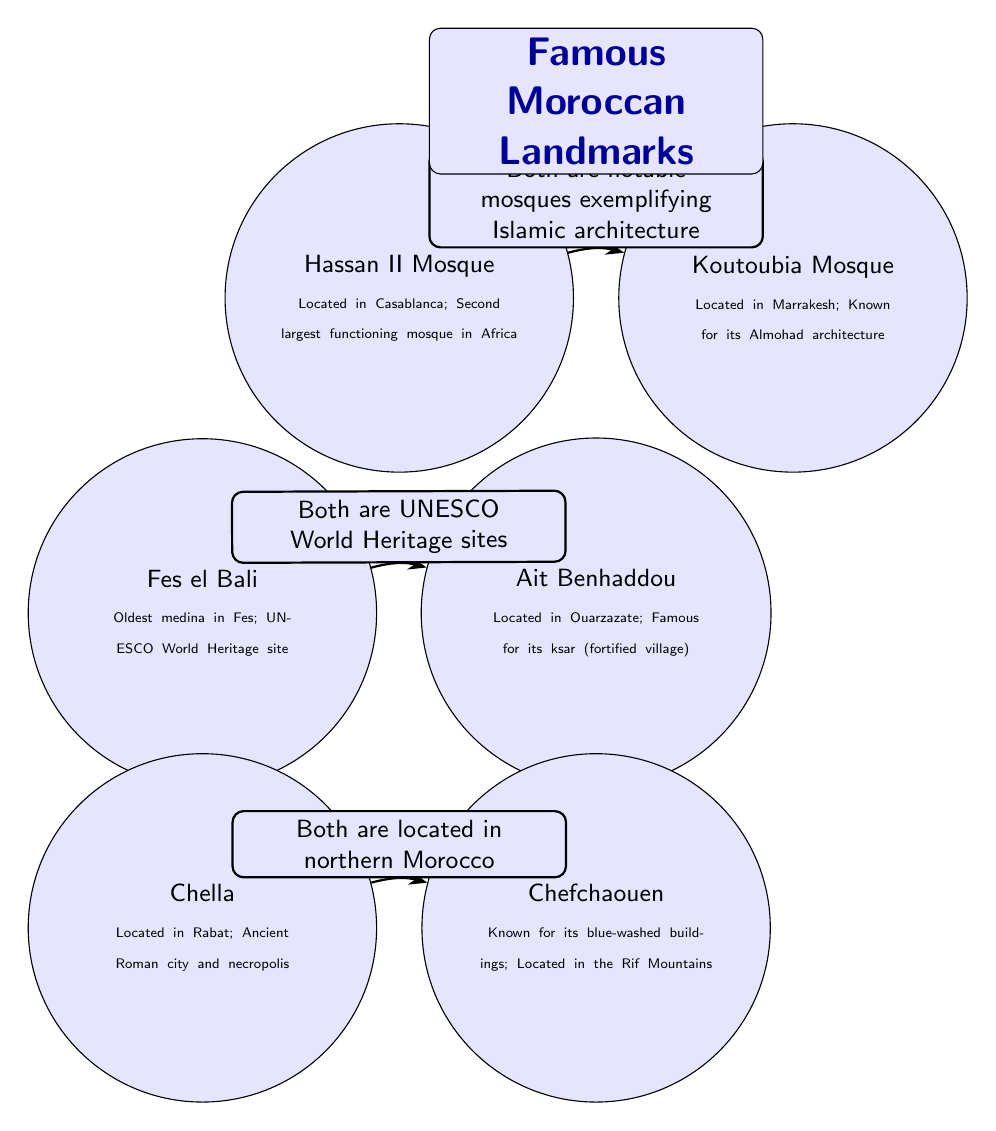What is the location of the Hassan II Mosque? The diagram specifies that the Hassan II Mosque is located in Casablanca. This information is provided directly in the description under the landmark node for Hassan II Mosque.
Answer: Casablanca How many landmarks are shown in the diagram? By counting the distinct nodes labeled in the diagram, there are a total of six landmarks featured: Hassan II Mosque, Koutoubia Mosque, Fes el Bali, Ait Benhaddou, Chella, and Chefchaouen.
Answer: 6 What landmark is known for its blue-washed buildings? The diagram indicates that Chefchaouen is known for its blue-washed buildings, as it directly states this within the landmark's description in the diagram.
Answer: Chefchaouen Which two landmarks are UNESCO World Heritage sites? The diagram connects Fes el Bali and Ait Benhaddou by noting that "Both are UNESCO World Heritage sites." By reasoning through this relationship, we can see that these two landmarks are recognized as such.
Answer: Fes el Bali and Ait Benhaddou What do the Koutoubia Mosque and Hassan II Mosque have in common? The diagram explicitly states a connection between Koutoubia Mosque and Hassan II Mosque that describes them as "Both are notable mosques exemplifying Islamic architecture." This indicates their shared characteristics related to architecture.
Answer: Notable mosques exemplifying Islamic architecture How are Chella and Chefchaouen connected in the diagram? The diagram connects Chella and Chefchaouen by the statement that "Both are located in northern Morocco." This indicates a geographical relationship between these two landmarks.
Answer: Located in northern Morocco 